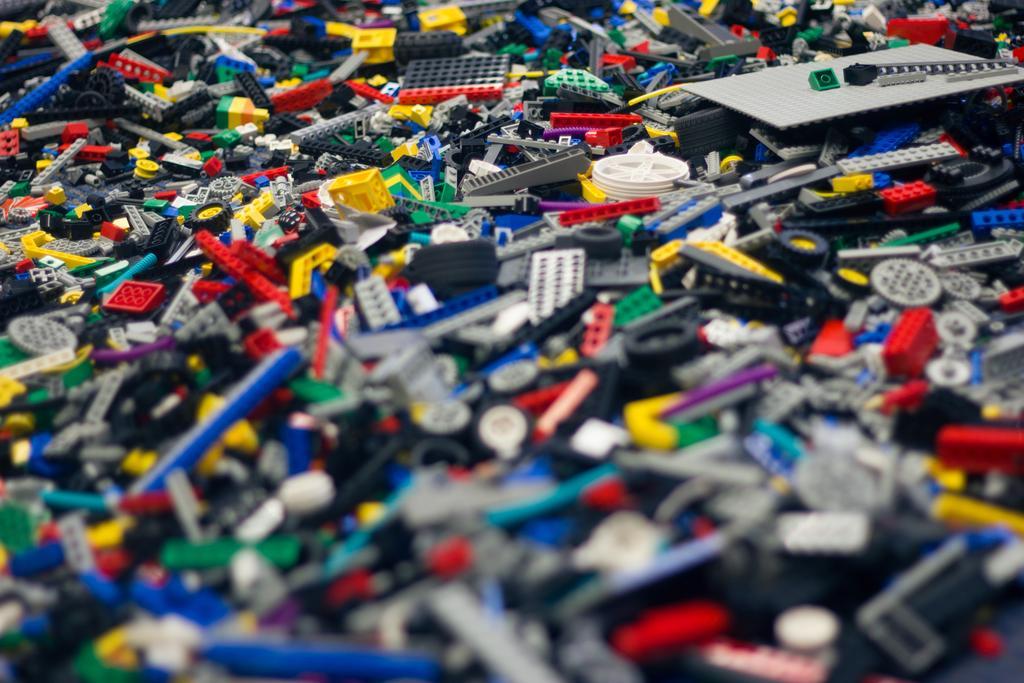How would you summarize this image in a sentence or two? In this picture we can see building blocks in different colors. 